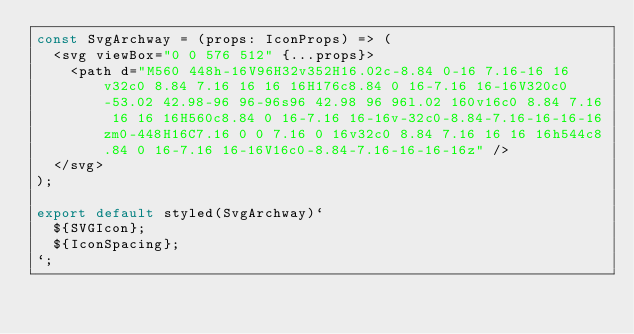Convert code to text. <code><loc_0><loc_0><loc_500><loc_500><_TypeScript_>const SvgArchway = (props: IconProps) => (
  <svg viewBox="0 0 576 512" {...props}>
    <path d="M560 448h-16V96H32v352H16.02c-8.84 0-16 7.16-16 16v32c0 8.84 7.16 16 16 16H176c8.84 0 16-7.16 16-16V320c0-53.02 42.98-96 96-96s96 42.98 96 96l.02 160v16c0 8.84 7.16 16 16 16H560c8.84 0 16-7.16 16-16v-32c0-8.84-7.16-16-16-16zm0-448H16C7.16 0 0 7.16 0 16v32c0 8.84 7.16 16 16 16h544c8.84 0 16-7.16 16-16V16c0-8.84-7.16-16-16-16z" />
  </svg>
);

export default styled(SvgArchway)`
  ${SVGIcon};
  ${IconSpacing};
`;
</code> 